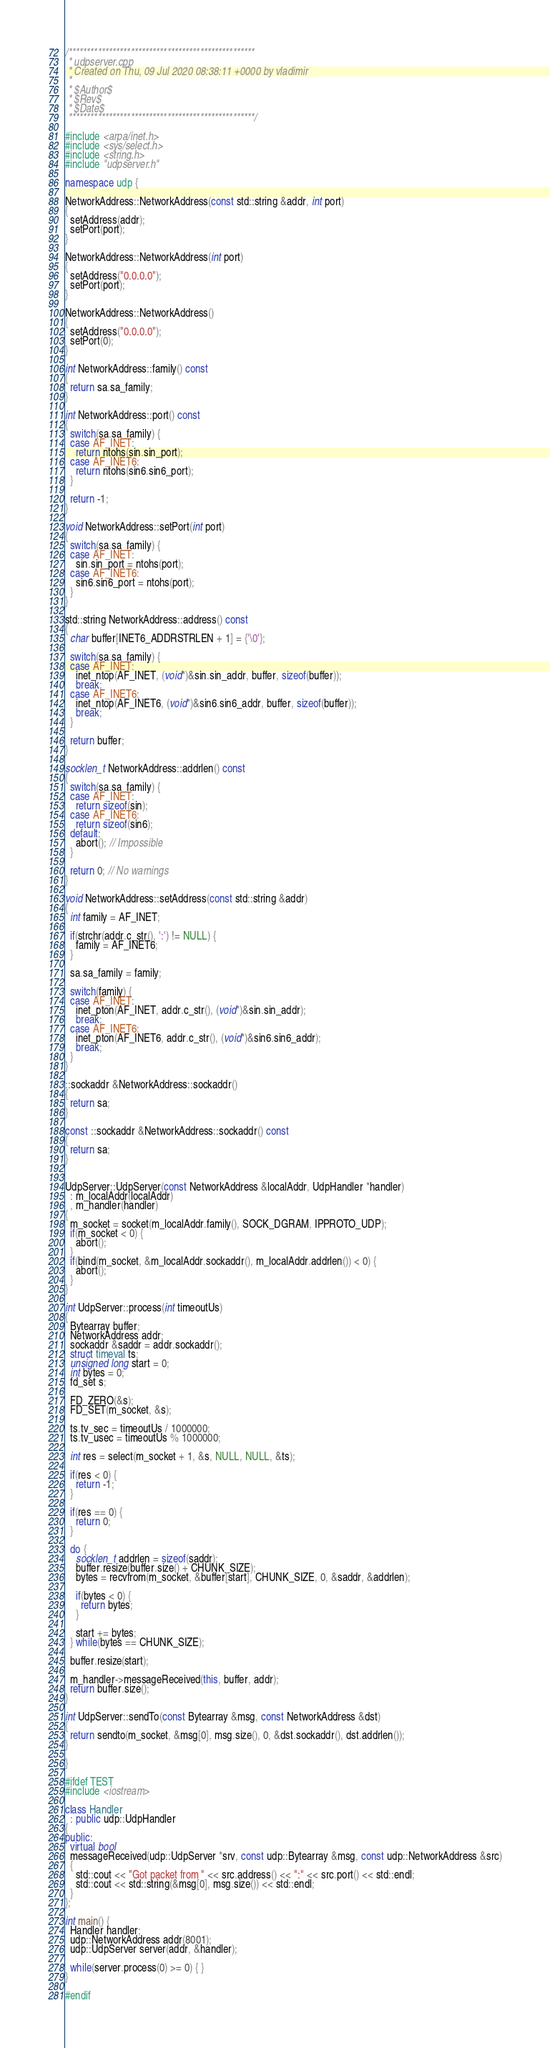Convert code to text. <code><loc_0><loc_0><loc_500><loc_500><_C++_>/***************************************************
 * udpserver.cpp
 * Created on Thu, 09 Jul 2020 08:38:11 +0000 by vladimir
 *
 * $Author$
 * $Rev$
 * $Date$
 ***************************************************/

#include <arpa/inet.h>
#include <sys/select.h>
#include <string.h>
#include "udpserver.h"

namespace udp {

NetworkAddress::NetworkAddress(const std::string &addr, int port)
{
  setAddress(addr);
  setPort(port);
}

NetworkAddress::NetworkAddress(int port)
{
  setAddress("0.0.0.0");
  setPort(port);
}

NetworkAddress::NetworkAddress()
{
  setAddress("0.0.0.0");
  setPort(0);
}

int NetworkAddress::family() const
{
  return sa.sa_family;
}

int NetworkAddress::port() const
{
  switch(sa.sa_family) {
  case AF_INET:
    return ntohs(sin.sin_port);
  case AF_INET6:
    return ntohs(sin6.sin6_port);
  }

  return -1;
}

void NetworkAddress::setPort(int port)
{
  switch(sa.sa_family) {
  case AF_INET:
    sin.sin_port = ntohs(port);
  case AF_INET6:
    sin6.sin6_port = ntohs(port);
  }
}

std::string NetworkAddress::address() const
{
  char buffer[INET6_ADDRSTRLEN + 1] = {'\0'};

  switch(sa.sa_family) {
  case AF_INET:
    inet_ntop(AF_INET, (void*)&sin.sin_addr, buffer, sizeof(buffer));
    break;
  case AF_INET6:
    inet_ntop(AF_INET6, (void*)&sin6.sin6_addr, buffer, sizeof(buffer));
    break;
  }

  return buffer;
}

socklen_t NetworkAddress::addrlen() const
{
  switch(sa.sa_family) {
  case AF_INET:
    return sizeof(sin);
  case AF_INET6:
    return sizeof(sin6);
  default:
    abort(); // Impossible
  }

  return 0; // No warnings
}

void NetworkAddress::setAddress(const std::string &addr)
{
  int family = AF_INET;

  if(strchr(addr.c_str(), ':') != NULL) {
    family = AF_INET6;
  }

  sa.sa_family = family;

  switch(family) {
  case AF_INET:
    inet_pton(AF_INET, addr.c_str(), (void*)&sin.sin_addr);
    break;
  case AF_INET6:
    inet_pton(AF_INET6, addr.c_str(), (void*)&sin6.sin6_addr);
    break;
  }
}

::sockaddr &NetworkAddress::sockaddr()
{
  return sa;
}

const ::sockaddr &NetworkAddress::sockaddr() const
{
  return sa;
}


UdpServer::UdpServer(const NetworkAddress &localAddr, UdpHandler *handler)
  : m_localAddr(localAddr)
  , m_handler(handler)
{
  m_socket = socket(m_localAddr.family(), SOCK_DGRAM, IPPROTO_UDP);
  if(m_socket < 0) {
    abort();
  }
  if(bind(m_socket, &m_localAddr.sockaddr(), m_localAddr.addrlen()) < 0) {
    abort();
  }
}

int UdpServer::process(int timeoutUs)
{
  Bytearray buffer;
  NetworkAddress addr;
  sockaddr &saddr = addr.sockaddr();
  struct timeval ts;
  unsigned long start = 0;
  int bytes = 0;
  fd_set s;

  FD_ZERO(&s);
  FD_SET(m_socket, &s);

  ts.tv_sec = timeoutUs / 1000000;
  ts.tv_usec = timeoutUs % 1000000;

  int res = select(m_socket + 1, &s, NULL, NULL, &ts);

  if(res < 0) {
    return -1;
  }

  if(res == 0) {
    return 0;
  }

  do {
    socklen_t addrlen = sizeof(saddr);
    buffer.resize(buffer.size() + CHUNK_SIZE);
    bytes = recvfrom(m_socket, &buffer[start], CHUNK_SIZE, 0, &saddr, &addrlen);

    if(bytes < 0) {
      return bytes;
    }

    start += bytes;
  } while(bytes == CHUNK_SIZE);

  buffer.resize(start);

  m_handler->messageReceived(this, buffer, addr);
  return buffer.size();
}

int UdpServer::sendTo(const Bytearray &msg, const NetworkAddress &dst)
{
  return sendto(m_socket, &msg[0], msg.size(), 0, &dst.sockaddr(), dst.addrlen());
}

}

#ifdef TEST
#include <iostream>

class Handler
  : public udp::UdpHandler
{
public:
  virtual bool 
  messageReceived(udp::UdpServer *srv, const udp::Bytearray &msg, const udp::NetworkAddress &src)
  {
    std::cout << "Got packet from " << src.address() << ":" << src.port() << std::endl;
    std::cout << std::string(&msg[0], msg.size()) << std::endl;
  }
};

int main() {
  Handler handler;
  udp::NetworkAddress addr(8001);
  udp::UdpServer server(addr, &handler);

  while(server.process(0) >= 0) { }
}

#endif
</code> 